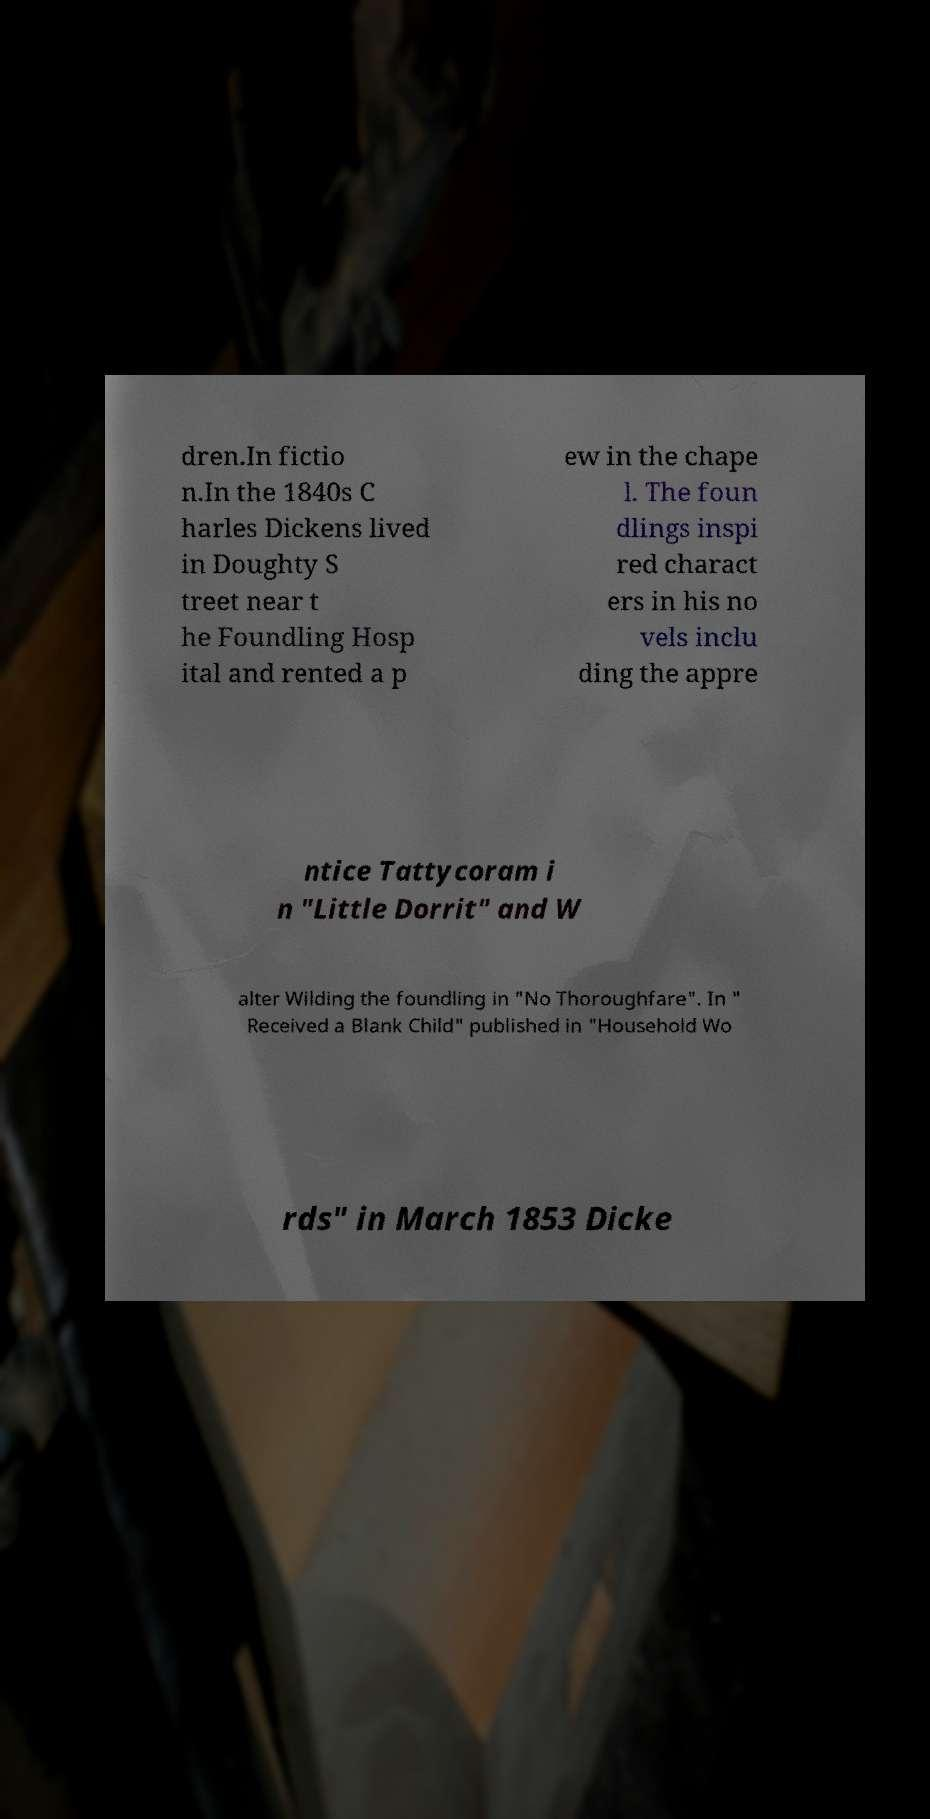Can you accurately transcribe the text from the provided image for me? dren.In fictio n.In the 1840s C harles Dickens lived in Doughty S treet near t he Foundling Hosp ital and rented a p ew in the chape l. The foun dlings inspi red charact ers in his no vels inclu ding the appre ntice Tattycoram i n "Little Dorrit" and W alter Wilding the foundling in "No Thoroughfare". In " Received a Blank Child" published in "Household Wo rds" in March 1853 Dicke 